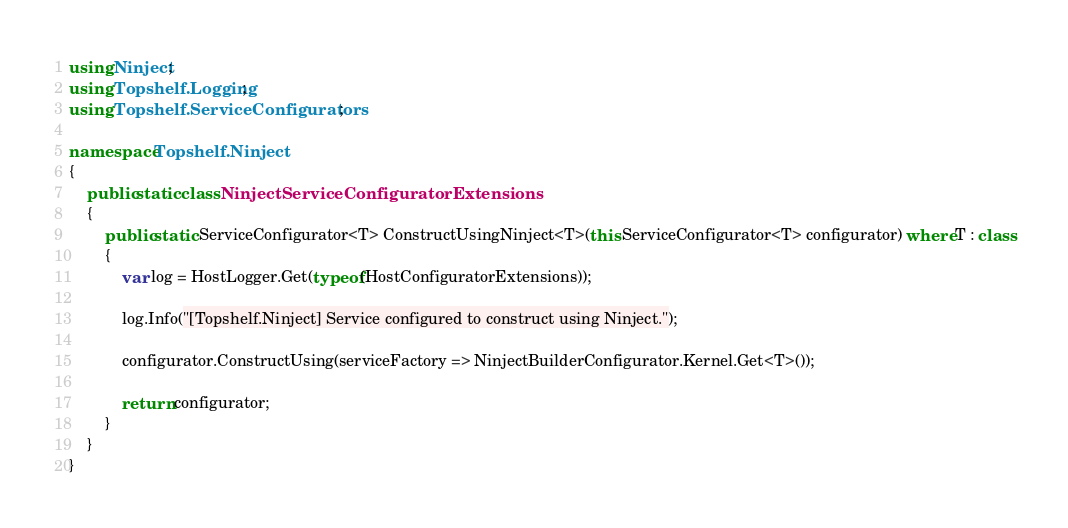Convert code to text. <code><loc_0><loc_0><loc_500><loc_500><_C#_>using Ninject;
using Topshelf.Logging;
using Topshelf.ServiceConfigurators;

namespace Topshelf.Ninject
{
    public static class NinjectServiceConfiguratorExtensions
    {
        public static ServiceConfigurator<T> ConstructUsingNinject<T>(this ServiceConfigurator<T> configurator) where T : class
        {
            var log = HostLogger.Get(typeof(HostConfiguratorExtensions));

            log.Info("[Topshelf.Ninject] Service configured to construct using Ninject.");

            configurator.ConstructUsing(serviceFactory => NinjectBuilderConfigurator.Kernel.Get<T>());

            return configurator;
        }
    }
}</code> 